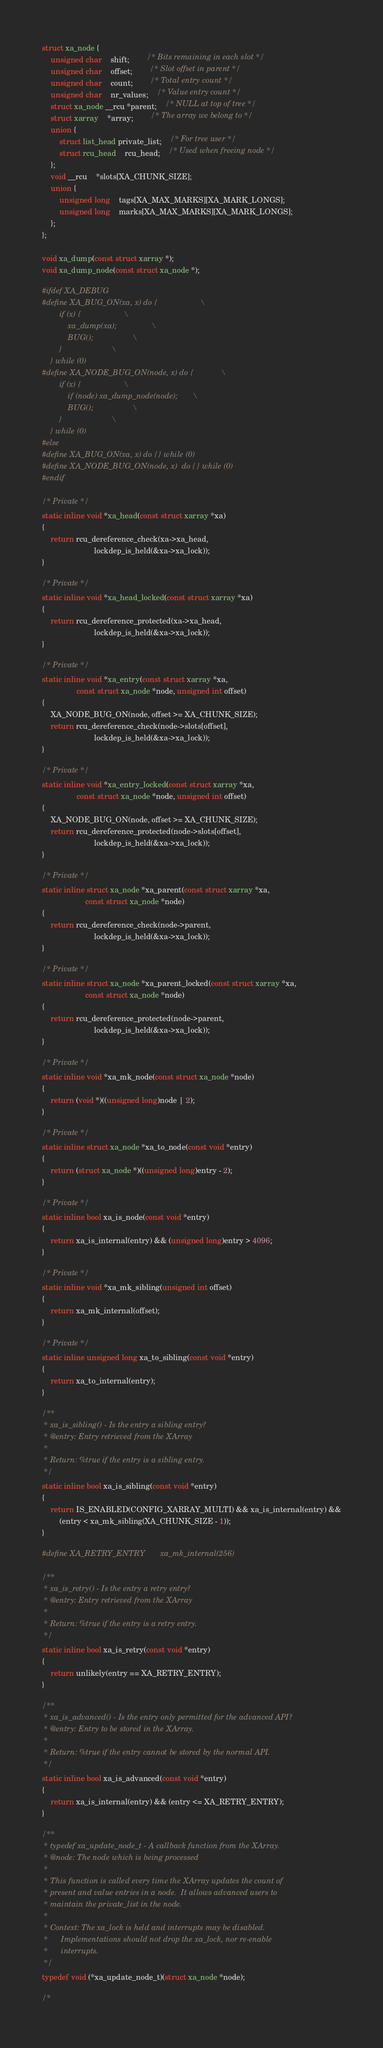<code> <loc_0><loc_0><loc_500><loc_500><_C_>struct xa_node {
	unsigned char	shift;		/* Bits remaining in each slot */
	unsigned char	offset;		/* Slot offset in parent */
	unsigned char	count;		/* Total entry count */
	unsigned char	nr_values;	/* Value entry count */
	struct xa_node __rcu *parent;	/* NULL at top of tree */
	struct xarray	*array;		/* The array we belong to */
	union {
		struct list_head private_list;	/* For tree user */
		struct rcu_head	rcu_head;	/* Used when freeing node */
	};
	void __rcu	*slots[XA_CHUNK_SIZE];
	union {
		unsigned long	tags[XA_MAX_MARKS][XA_MARK_LONGS];
		unsigned long	marks[XA_MAX_MARKS][XA_MARK_LONGS];
	};
};

void xa_dump(const struct xarray *);
void xa_dump_node(const struct xa_node *);

#ifdef XA_DEBUG
#define XA_BUG_ON(xa, x) do {					\
		if (x) {					\
			xa_dump(xa);				\
			BUG();					\
		}						\
	} while (0)
#define XA_NODE_BUG_ON(node, x) do {				\
		if (x) {					\
			if (node) xa_dump_node(node);		\
			BUG();					\
		}						\
	} while (0)
#else
#define XA_BUG_ON(xa, x)	do { } while (0)
#define XA_NODE_BUG_ON(node, x)	do { } while (0)
#endif

/* Private */
static inline void *xa_head(const struct xarray *xa)
{
	return rcu_dereference_check(xa->xa_head,
						lockdep_is_held(&xa->xa_lock));
}

/* Private */
static inline void *xa_head_locked(const struct xarray *xa)
{
	return rcu_dereference_protected(xa->xa_head,
						lockdep_is_held(&xa->xa_lock));
}

/* Private */
static inline void *xa_entry(const struct xarray *xa,
				const struct xa_node *node, unsigned int offset)
{
	XA_NODE_BUG_ON(node, offset >= XA_CHUNK_SIZE);
	return rcu_dereference_check(node->slots[offset],
						lockdep_is_held(&xa->xa_lock));
}

/* Private */
static inline void *xa_entry_locked(const struct xarray *xa,
				const struct xa_node *node, unsigned int offset)
{
	XA_NODE_BUG_ON(node, offset >= XA_CHUNK_SIZE);
	return rcu_dereference_protected(node->slots[offset],
						lockdep_is_held(&xa->xa_lock));
}

/* Private */
static inline struct xa_node *xa_parent(const struct xarray *xa,
					const struct xa_node *node)
{
	return rcu_dereference_check(node->parent,
						lockdep_is_held(&xa->xa_lock));
}

/* Private */
static inline struct xa_node *xa_parent_locked(const struct xarray *xa,
					const struct xa_node *node)
{
	return rcu_dereference_protected(node->parent,
						lockdep_is_held(&xa->xa_lock));
}

/* Private */
static inline void *xa_mk_node(const struct xa_node *node)
{
	return (void *)((unsigned long)node | 2);
}

/* Private */
static inline struct xa_node *xa_to_node(const void *entry)
{
	return (struct xa_node *)((unsigned long)entry - 2);
}

/* Private */
static inline bool xa_is_node(const void *entry)
{
	return xa_is_internal(entry) && (unsigned long)entry > 4096;
}

/* Private */
static inline void *xa_mk_sibling(unsigned int offset)
{
	return xa_mk_internal(offset);
}

/* Private */
static inline unsigned long xa_to_sibling(const void *entry)
{
	return xa_to_internal(entry);
}

/**
 * xa_is_sibling() - Is the entry a sibling entry?
 * @entry: Entry retrieved from the XArray
 *
 * Return: %true if the entry is a sibling entry.
 */
static inline bool xa_is_sibling(const void *entry)
{
	return IS_ENABLED(CONFIG_XARRAY_MULTI) && xa_is_internal(entry) &&
		(entry < xa_mk_sibling(XA_CHUNK_SIZE - 1));
}

#define XA_RETRY_ENTRY		xa_mk_internal(256)

/**
 * xa_is_retry() - Is the entry a retry entry?
 * @entry: Entry retrieved from the XArray
 *
 * Return: %true if the entry is a retry entry.
 */
static inline bool xa_is_retry(const void *entry)
{
	return unlikely(entry == XA_RETRY_ENTRY);
}

/**
 * xa_is_advanced() - Is the entry only permitted for the advanced API?
 * @entry: Entry to be stored in the XArray.
 *
 * Return: %true if the entry cannot be stored by the normal API.
 */
static inline bool xa_is_advanced(const void *entry)
{
	return xa_is_internal(entry) && (entry <= XA_RETRY_ENTRY);
}

/**
 * typedef xa_update_node_t - A callback function from the XArray.
 * @node: The node which is being processed
 *
 * This function is called every time the XArray updates the count of
 * present and value entries in a node.  It allows advanced users to
 * maintain the private_list in the node.
 *
 * Context: The xa_lock is held and interrupts may be disabled.
 *	    Implementations should not drop the xa_lock, nor re-enable
 *	    interrupts.
 */
typedef void (*xa_update_node_t)(struct xa_node *node);

/*</code> 